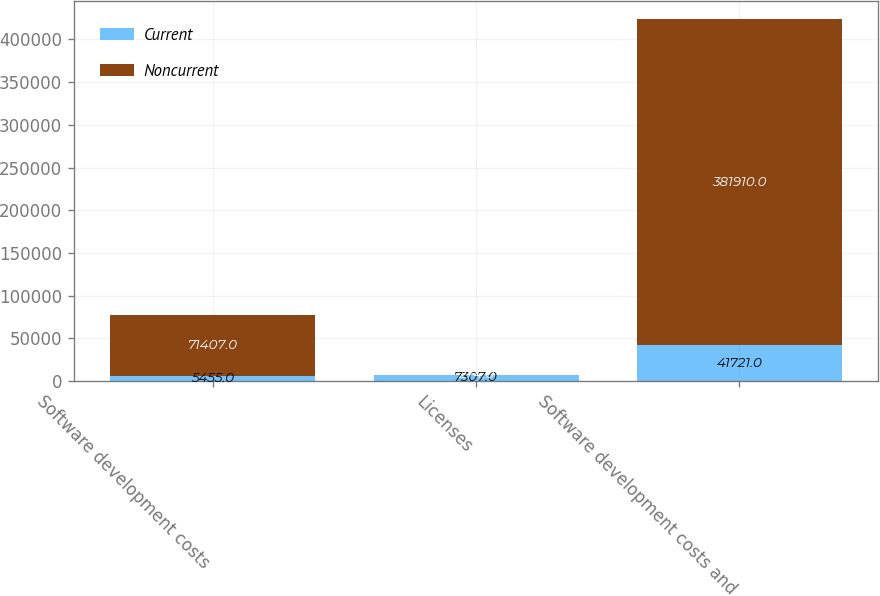<chart> <loc_0><loc_0><loc_500><loc_500><stacked_bar_chart><ecel><fcel>Software development costs<fcel>Licenses<fcel>Software development costs and<nl><fcel>Current<fcel>5455<fcel>7307<fcel>41721<nl><fcel>Noncurrent<fcel>71407<fcel>274<fcel>381910<nl></chart> 